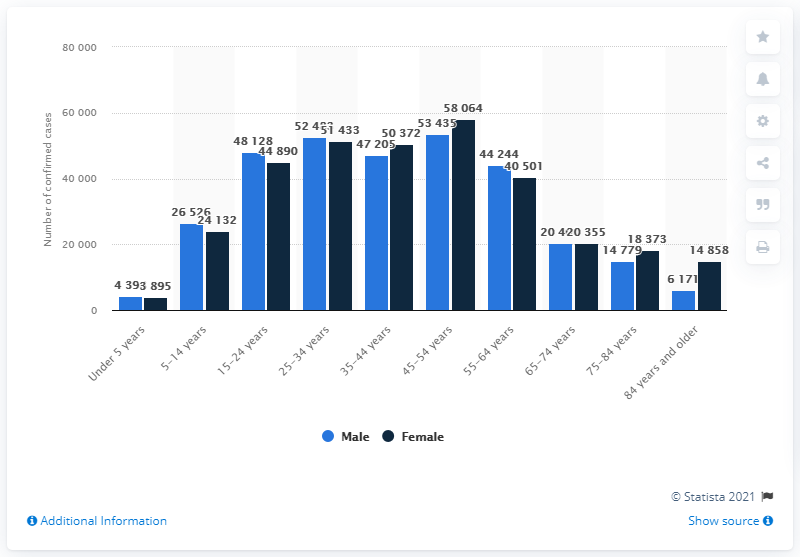Point out several critical features in this image. As of June 2021, the age group with the highest number of confirmed coronavirus cases in Austria was individuals aged 45-54 years old. 